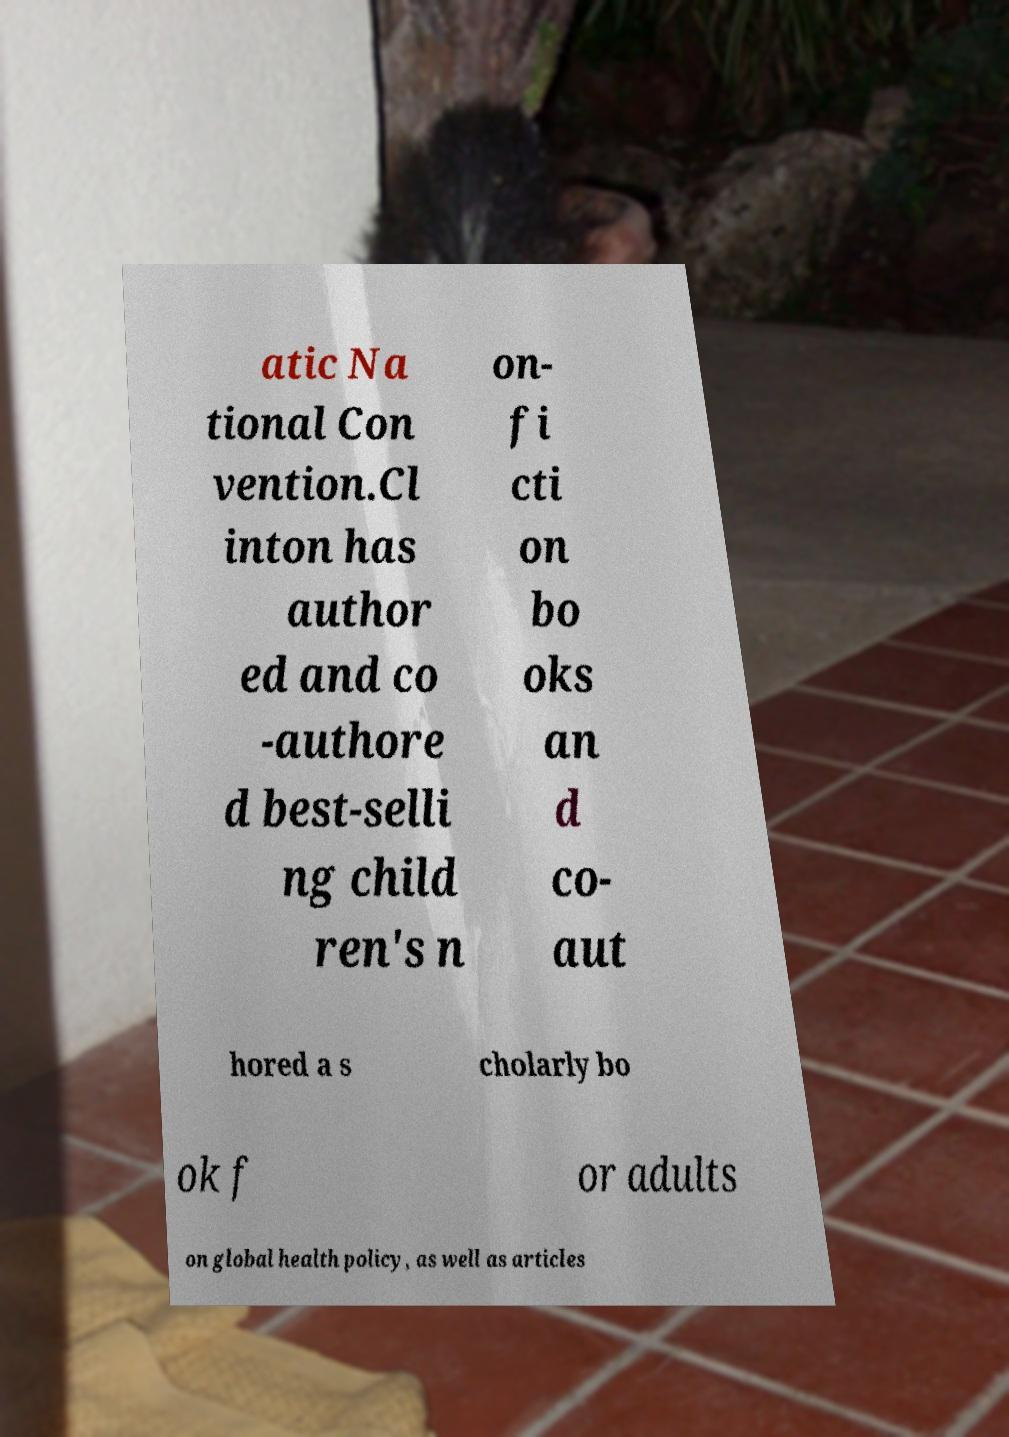I need the written content from this picture converted into text. Can you do that? atic Na tional Con vention.Cl inton has author ed and co -authore d best-selli ng child ren's n on- fi cti on bo oks an d co- aut hored a s cholarly bo ok f or adults on global health policy, as well as articles 